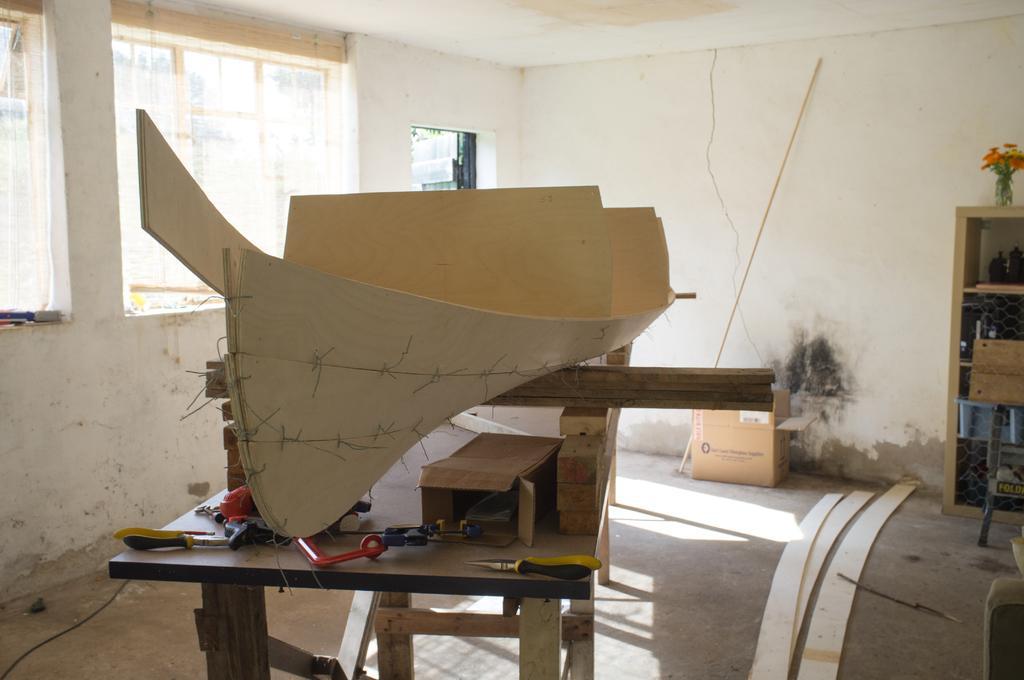How would you summarize this image in a sentence or two? This is an image of the room with windows, also there is a cardboard box on the floor beside that there is a shelf with flower vase kept on the top also there is a table with so many waste particles and some tool items. 